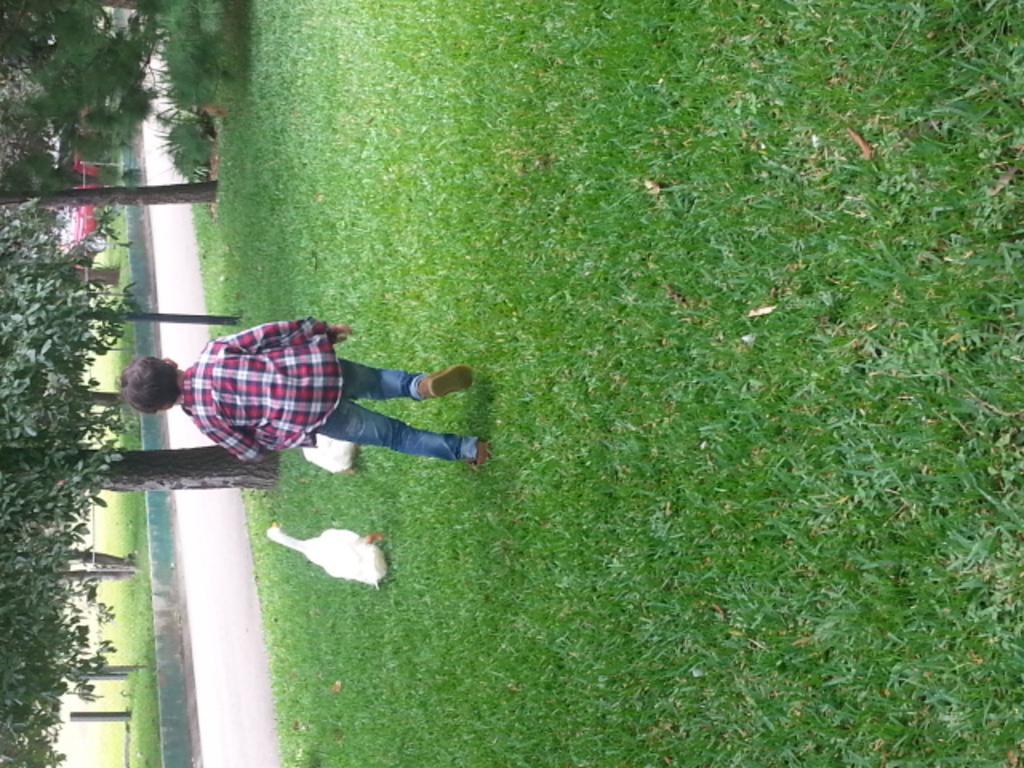In one or two sentences, can you explain what this image depicts? In this image we can see a kid wearing checks shirt, blue jeans running on the ground there are two ducks which are running and on left side of the image there is road, trees and in the foreground of the image there is grass. 